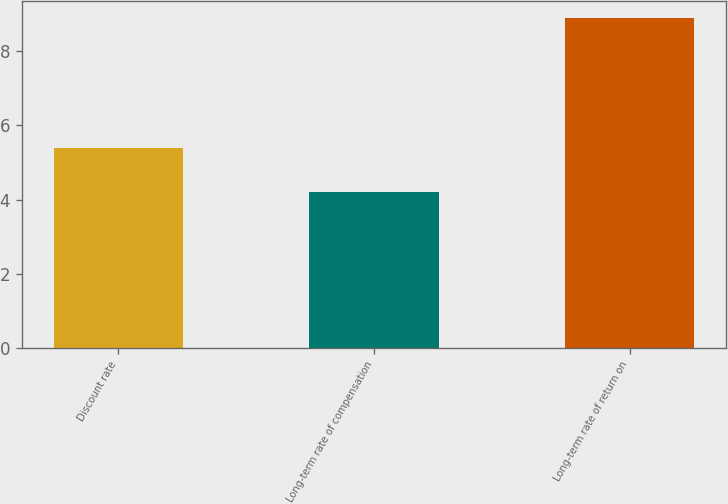Convert chart. <chart><loc_0><loc_0><loc_500><loc_500><bar_chart><fcel>Discount rate<fcel>Long-term rate of compensation<fcel>Long-term rate of return on<nl><fcel>5.4<fcel>4.2<fcel>8.9<nl></chart> 